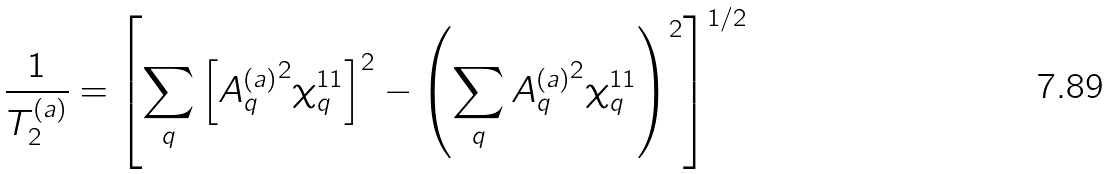Convert formula to latex. <formula><loc_0><loc_0><loc_500><loc_500>\frac { 1 } { T _ { 2 } ^ { ( a ) } } = \left [ \sum _ { q } \left [ { A _ { q } ^ { ( a ) } } ^ { 2 } \chi ^ { 1 1 } _ { q } \right ] ^ { 2 } - \left ( \sum _ { q } { A _ { q } ^ { ( a ) } } ^ { 2 } \chi ^ { 1 1 } _ { q } \right ) ^ { 2 } \right ] ^ { 1 / 2 }</formula> 